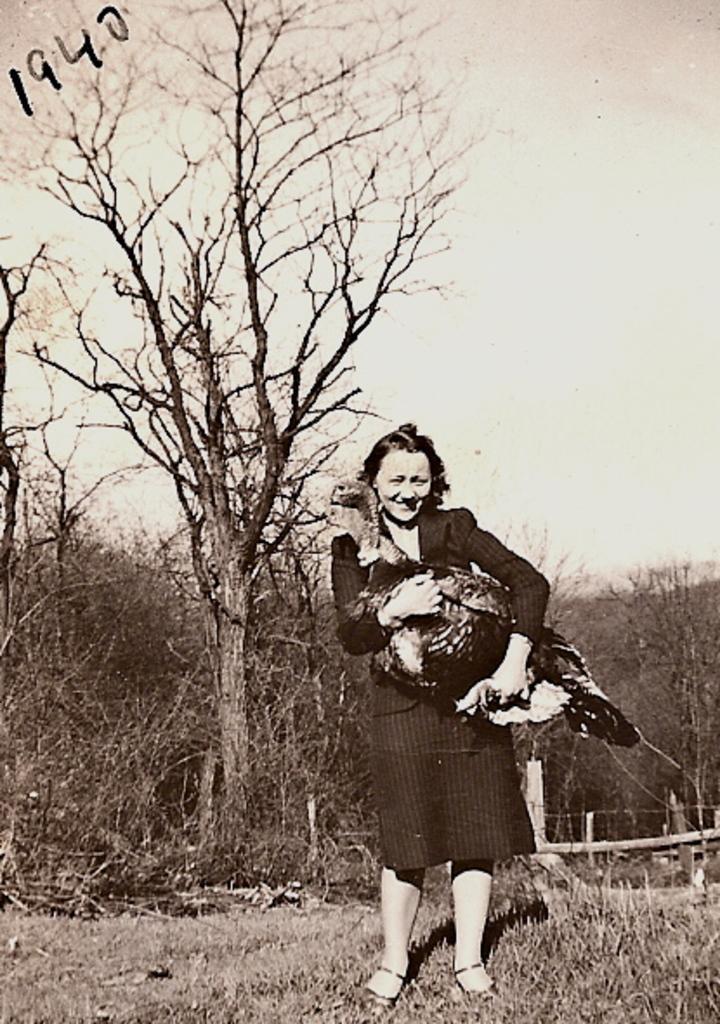Describe this image in one or two sentences. In this picture we can see a woman holding a bird, behind we can see some trees. 